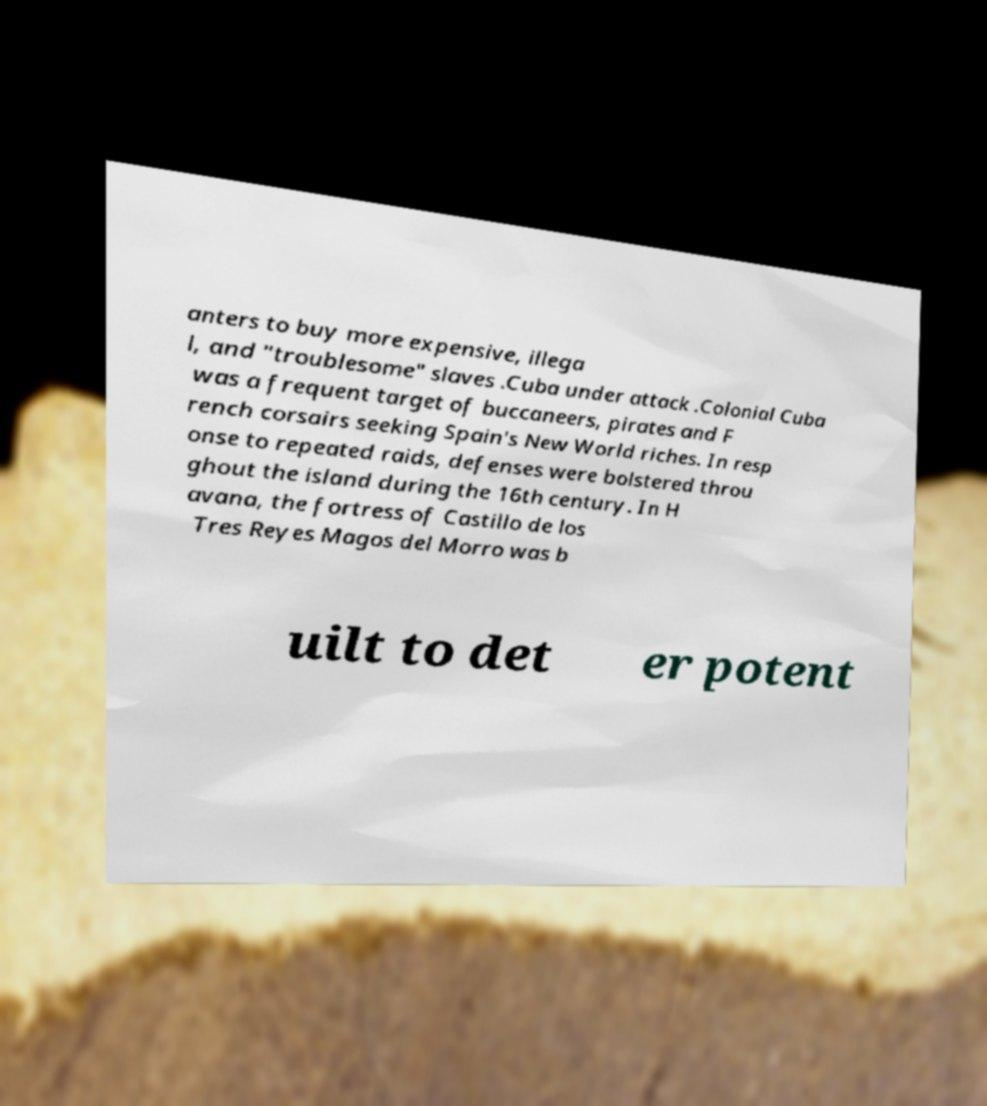What messages or text are displayed in this image? I need them in a readable, typed format. anters to buy more expensive, illega l, and "troublesome" slaves .Cuba under attack .Colonial Cuba was a frequent target of buccaneers, pirates and F rench corsairs seeking Spain's New World riches. In resp onse to repeated raids, defenses were bolstered throu ghout the island during the 16th century. In H avana, the fortress of Castillo de los Tres Reyes Magos del Morro was b uilt to det er potent 